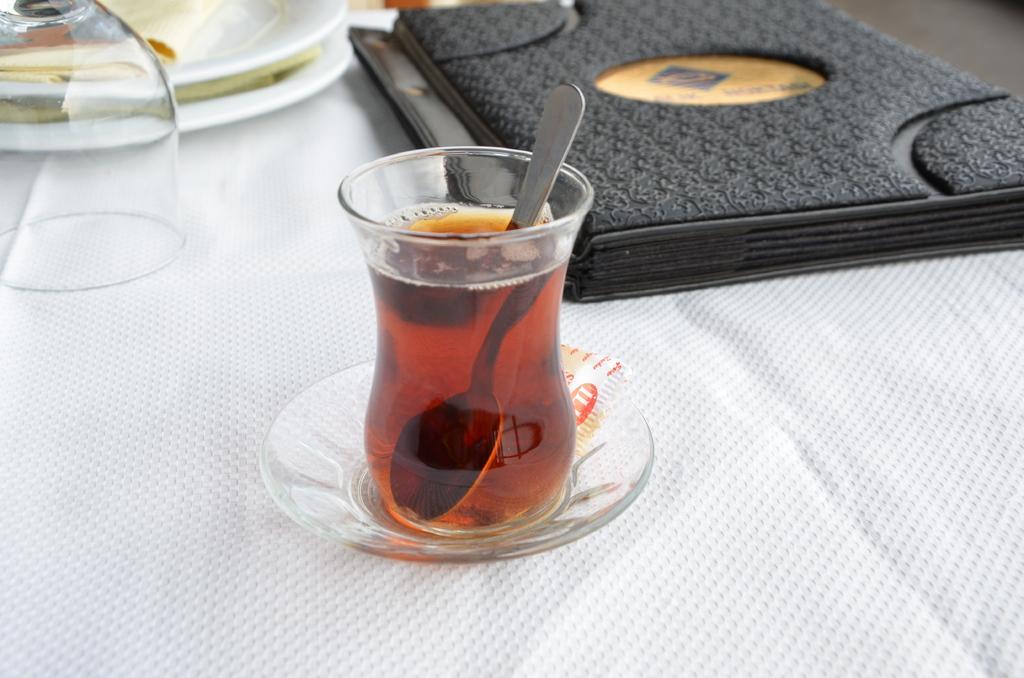Can you describe this image briefly? In the picture we can see a table with a white color cloth on it and on it we can see a glass on the saucer and in the glass we can see some drink and spoon and beside it we can see another glass and some plates and beside it we can see a file which is black in color with some designs on it. 